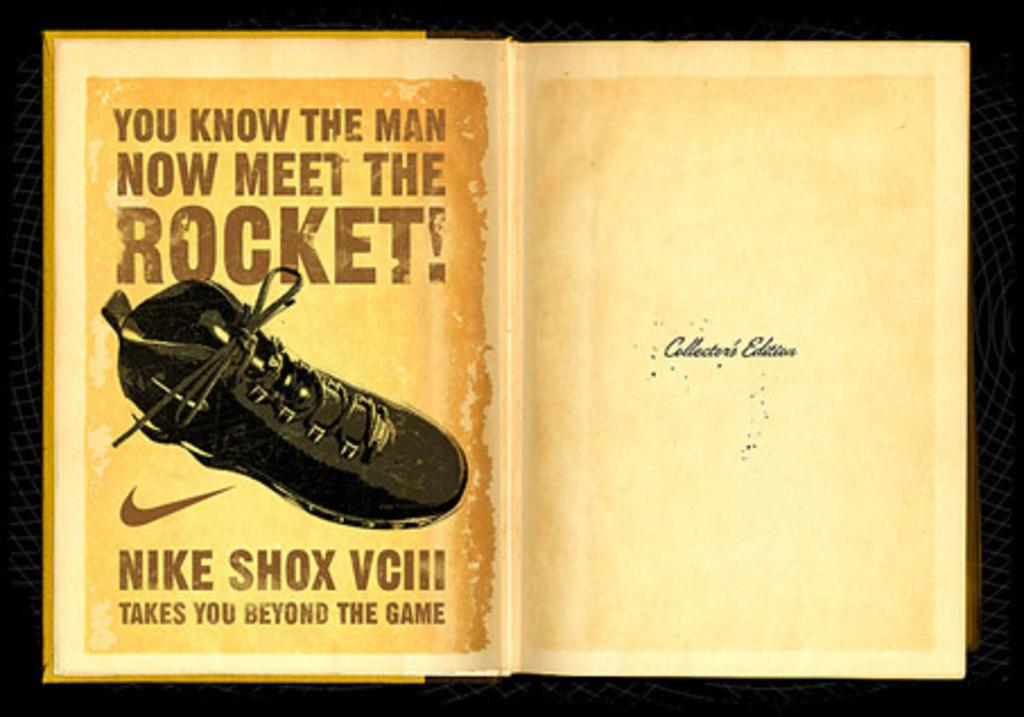What is featured on the poster in the image? The poster contains a shoe. What else can be seen on the poster besides the shoe? There is text written on the poster. How many owls are sitting on the arm in the image? There is no arm or owl present in the image. What type of quicksand can be seen surrounding the shoe in the image? There is no quicksand present in the image; it only features a poster with a shoe and text. 